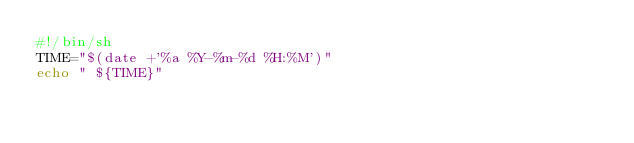Convert code to text. <code><loc_0><loc_0><loc_500><loc_500><_Bash_>#!/bin/sh
TIME="$(date +'%a %Y-%m-%d %H:%M')"
echo " ${TIME}"
</code> 